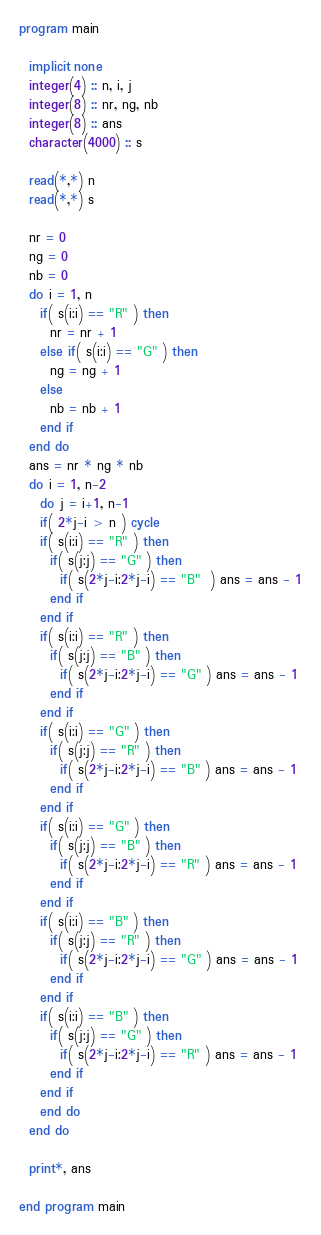Convert code to text. <code><loc_0><loc_0><loc_500><loc_500><_FORTRAN_>program main
  
  implicit none
  integer(4) :: n, i, j
  integer(8) :: nr, ng, nb
  integer(8) :: ans
  character(4000) :: s
  
  read(*,*) n
  read(*,*) s
  
  nr = 0
  ng = 0
  nb = 0
  do i = 1, n
    if( s(i:i) == "R" ) then
      nr = nr + 1
    else if( s(i:i) == "G" ) then
      ng = ng + 1
    else
      nb = nb + 1
    end if
  end do
  ans = nr * ng * nb
  do i = 1, n-2
    do j = i+1, n-1
    if( 2*j-i > n ) cycle
    if( s(i:i) == "R" ) then
      if( s(j:j) == "G" ) then
        if( s(2*j-i:2*j-i) == "B"  ) ans = ans - 1
      end if
    end if
    if( s(i:i) == "R" ) then
      if( s(j:j) == "B" ) then
        if( s(2*j-i:2*j-i) == "G" ) ans = ans - 1
      end if
    end if
    if( s(i:i) == "G" ) then
      if( s(j:j) == "R" ) then
        if( s(2*j-i:2*j-i) == "B" ) ans = ans - 1
      end if
    end if
    if( s(i:i) == "G" ) then
      if( s(j:j) == "B" ) then
        if( s(2*j-i:2*j-i) == "R" ) ans = ans - 1
      end if
    end if
    if( s(i:i) == "B" ) then
      if( s(j:j) == "R" ) then
        if( s(2*j-i:2*j-i) == "G" ) ans = ans - 1
      end if
    end if
    if( s(i:i) == "B" ) then
      if( s(j:j) == "G" ) then
        if( s(2*j-i:2*j-i) == "R" ) ans = ans - 1
      end if
    end if
    end do
  end do

  print*, ans 

end program main
</code> 